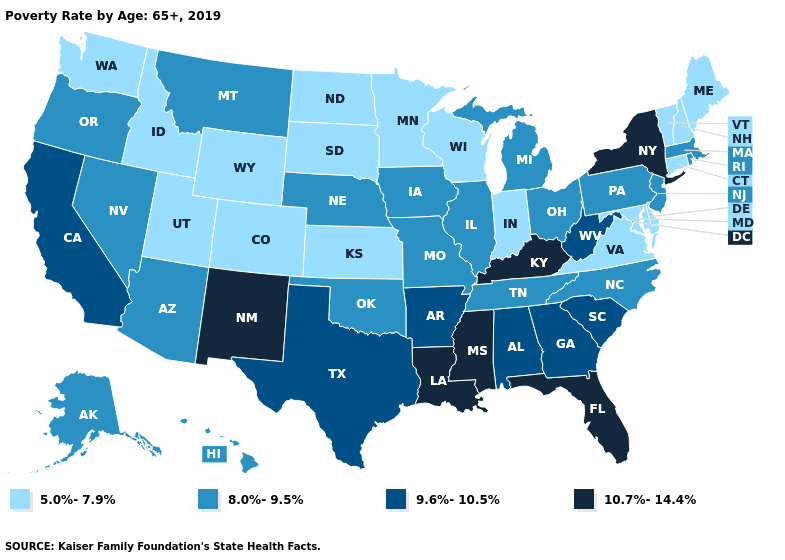Name the states that have a value in the range 9.6%-10.5%?
Answer briefly. Alabama, Arkansas, California, Georgia, South Carolina, Texas, West Virginia. What is the value of Tennessee?
Answer briefly. 8.0%-9.5%. Name the states that have a value in the range 9.6%-10.5%?
Quick response, please. Alabama, Arkansas, California, Georgia, South Carolina, Texas, West Virginia. What is the value of Rhode Island?
Write a very short answer. 8.0%-9.5%. What is the lowest value in the USA?
Write a very short answer. 5.0%-7.9%. What is the highest value in the USA?
Answer briefly. 10.7%-14.4%. What is the value of Idaho?
Give a very brief answer. 5.0%-7.9%. What is the value of Maryland?
Write a very short answer. 5.0%-7.9%. Does Maine have the highest value in the USA?
Give a very brief answer. No. Name the states that have a value in the range 10.7%-14.4%?
Quick response, please. Florida, Kentucky, Louisiana, Mississippi, New Mexico, New York. What is the highest value in the USA?
Short answer required. 10.7%-14.4%. Does New York have the highest value in the Northeast?
Answer briefly. Yes. Is the legend a continuous bar?
Concise answer only. No. Does Mississippi have a lower value than Delaware?
Quick response, please. No. Does North Carolina have a lower value than Oregon?
Concise answer only. No. 